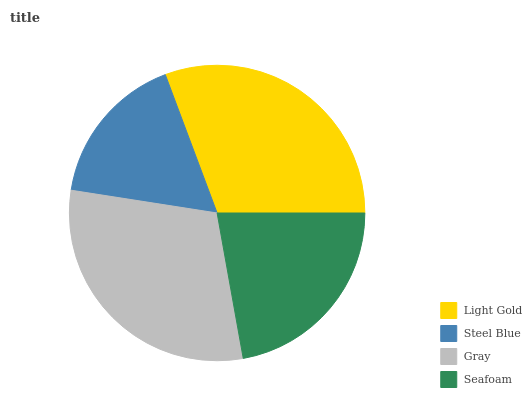Is Steel Blue the minimum?
Answer yes or no. Yes. Is Light Gold the maximum?
Answer yes or no. Yes. Is Gray the minimum?
Answer yes or no. No. Is Gray the maximum?
Answer yes or no. No. Is Gray greater than Steel Blue?
Answer yes or no. Yes. Is Steel Blue less than Gray?
Answer yes or no. Yes. Is Steel Blue greater than Gray?
Answer yes or no. No. Is Gray less than Steel Blue?
Answer yes or no. No. Is Gray the high median?
Answer yes or no. Yes. Is Seafoam the low median?
Answer yes or no. Yes. Is Seafoam the high median?
Answer yes or no. No. Is Steel Blue the low median?
Answer yes or no. No. 